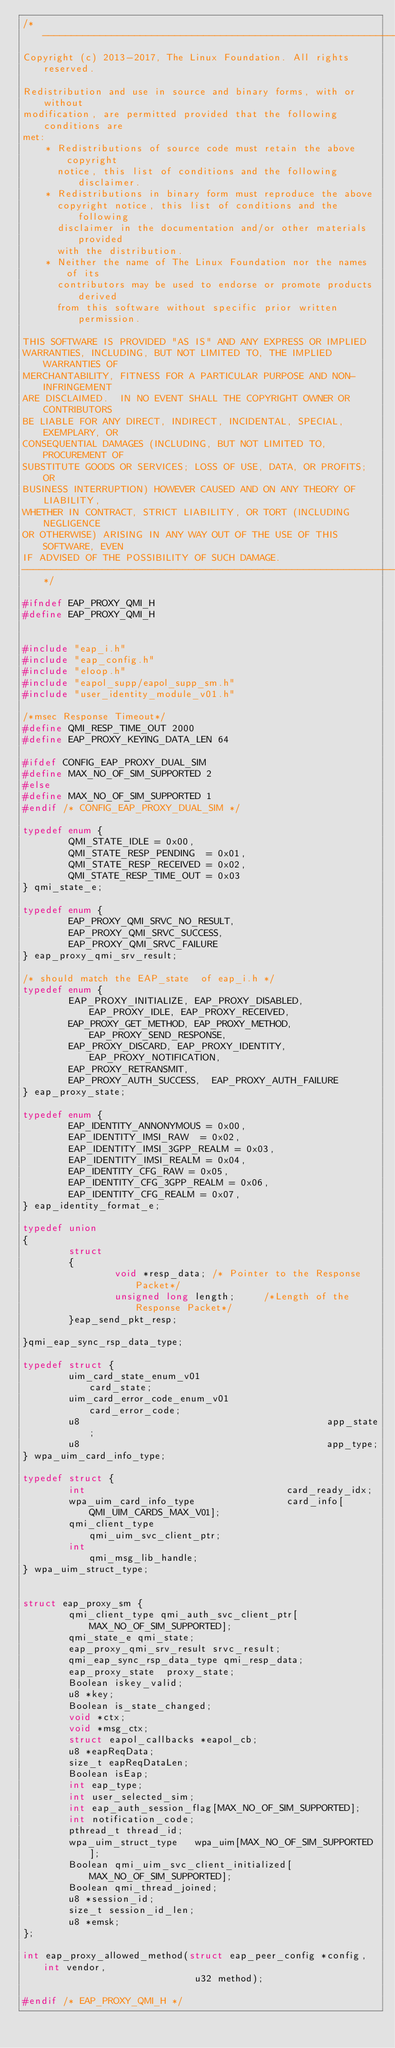<code> <loc_0><loc_0><loc_500><loc_500><_C_>/*--------------------------------------------------------------------------
Copyright (c) 2013-2017, The Linux Foundation. All rights reserved.

Redistribution and use in source and binary forms, with or without
modification, are permitted provided that the following conditions are
met:
    * Redistributions of source code must retain the above copyright
      notice, this list of conditions and the following disclaimer.
    * Redistributions in binary form must reproduce the above
      copyright notice, this list of conditions and the following
      disclaimer in the documentation and/or other materials provided
      with the distribution.
    * Neither the name of The Linux Foundation nor the names of its
      contributors may be used to endorse or promote products derived
      from this software without specific prior written permission.

THIS SOFTWARE IS PROVIDED "AS IS" AND ANY EXPRESS OR IMPLIED
WARRANTIES, INCLUDING, BUT NOT LIMITED TO, THE IMPLIED WARRANTIES OF
MERCHANTABILITY, FITNESS FOR A PARTICULAR PURPOSE AND NON-INFRINGEMENT
ARE DISCLAIMED.  IN NO EVENT SHALL THE COPYRIGHT OWNER OR CONTRIBUTORS
BE LIABLE FOR ANY DIRECT, INDIRECT, INCIDENTAL, SPECIAL, EXEMPLARY, OR
CONSEQUENTIAL DAMAGES (INCLUDING, BUT NOT LIMITED TO, PROCUREMENT OF
SUBSTITUTE GOODS OR SERVICES; LOSS OF USE, DATA, OR PROFITS; OR
BUSINESS INTERRUPTION) HOWEVER CAUSED AND ON ANY THEORY OF LIABILITY,
WHETHER IN CONTRACT, STRICT LIABILITY, OR TORT (INCLUDING NEGLIGENCE
OR OTHERWISE) ARISING IN ANY WAY OUT OF THE USE OF THIS SOFTWARE, EVEN
IF ADVISED OF THE POSSIBILITY OF SUCH DAMAGE.
--------------------------------------------------------------------------*/

#ifndef EAP_PROXY_QMI_H
#define EAP_PROXY_QMI_H


#include "eap_i.h"
#include "eap_config.h"
#include "eloop.h"
#include "eapol_supp/eapol_supp_sm.h"
#include "user_identity_module_v01.h"

/*msec Response Timeout*/
#define QMI_RESP_TIME_OUT 2000
#define EAP_PROXY_KEYING_DATA_LEN 64

#ifdef CONFIG_EAP_PROXY_DUAL_SIM
#define MAX_NO_OF_SIM_SUPPORTED 2
#else
#define MAX_NO_OF_SIM_SUPPORTED 1
#endif /* CONFIG_EAP_PROXY_DUAL_SIM */

typedef enum {
        QMI_STATE_IDLE = 0x00,
        QMI_STATE_RESP_PENDING  = 0x01,
        QMI_STATE_RESP_RECEIVED = 0x02,
        QMI_STATE_RESP_TIME_OUT = 0x03
} qmi_state_e;

typedef enum {
        EAP_PROXY_QMI_SRVC_NO_RESULT,
        EAP_PROXY_QMI_SRVC_SUCCESS,
        EAP_PROXY_QMI_SRVC_FAILURE
} eap_proxy_qmi_srv_result;

/* should match the EAP_state  of eap_i.h */
typedef enum {
        EAP_PROXY_INITIALIZE, EAP_PROXY_DISABLED, EAP_PROXY_IDLE, EAP_PROXY_RECEIVED,
        EAP_PROXY_GET_METHOD, EAP_PROXY_METHOD, EAP_PROXY_SEND_RESPONSE,
        EAP_PROXY_DISCARD, EAP_PROXY_IDENTITY, EAP_PROXY_NOTIFICATION,
        EAP_PROXY_RETRANSMIT,
        EAP_PROXY_AUTH_SUCCESS,  EAP_PROXY_AUTH_FAILURE
} eap_proxy_state;

typedef enum {
        EAP_IDENTITY_ANNONYMOUS = 0x00,
        EAP_IDENTITY_IMSI_RAW  = 0x02,
        EAP_IDENTITY_IMSI_3GPP_REALM = 0x03,
        EAP_IDENTITY_IMSI_REALM = 0x04,
        EAP_IDENTITY_CFG_RAW = 0x05,
        EAP_IDENTITY_CFG_3GPP_REALM = 0x06,
        EAP_IDENTITY_CFG_REALM = 0x07,
} eap_identity_format_e;

typedef union
{
        struct
        {
                void *resp_data; /* Pointer to the Response Packet*/
                unsigned long length;     /*Length of the Response Packet*/
        }eap_send_pkt_resp;

}qmi_eap_sync_rsp_data_type;

typedef struct {
        uim_card_state_enum_v01                      card_state;
        uim_card_error_code_enum_v01                 card_error_code;
        u8                                           app_state;
        u8                                           app_type;
} wpa_uim_card_info_type;

typedef struct {
        int                                   card_ready_idx;
        wpa_uim_card_info_type                card_info[QMI_UIM_CARDS_MAX_V01];
        qmi_client_type                       qmi_uim_svc_client_ptr;
        int                                   qmi_msg_lib_handle;
} wpa_uim_struct_type;


struct eap_proxy_sm {
        qmi_client_type qmi_auth_svc_client_ptr[MAX_NO_OF_SIM_SUPPORTED];
        qmi_state_e qmi_state;
        eap_proxy_qmi_srv_result srvc_result;
        qmi_eap_sync_rsp_data_type qmi_resp_data;
        eap_proxy_state  proxy_state;
        Boolean iskey_valid;
        u8 *key;
        Boolean is_state_changed;
        void *ctx;
        void *msg_ctx;
        struct eapol_callbacks *eapol_cb;
        u8 *eapReqData;
        size_t eapReqDataLen;
        Boolean isEap;
        int eap_type;
        int user_selected_sim;
        int eap_auth_session_flag[MAX_NO_OF_SIM_SUPPORTED];
        int notification_code;
        pthread_t thread_id;
        wpa_uim_struct_type   wpa_uim[MAX_NO_OF_SIM_SUPPORTED];
        Boolean qmi_uim_svc_client_initialized[MAX_NO_OF_SIM_SUPPORTED];
        Boolean qmi_thread_joined;
        u8 *session_id;
        size_t session_id_len;
        u8 *emsk;
};

int eap_proxy_allowed_method(struct eap_peer_config *config, int vendor,
                              u32 method);

#endif /* EAP_PROXY_QMI_H */
</code> 